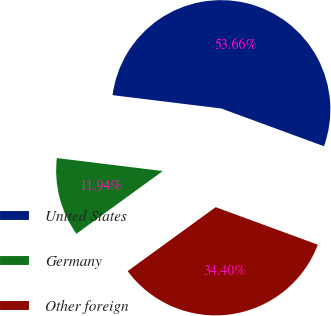<chart> <loc_0><loc_0><loc_500><loc_500><pie_chart><fcel>United States<fcel>Germany<fcel>Other foreign<nl><fcel>53.66%<fcel>11.94%<fcel>34.4%<nl></chart> 